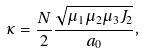<formula> <loc_0><loc_0><loc_500><loc_500>\kappa = \frac { N } { 2 } \frac { \sqrt { \mu _ { 1 } \mu _ { 2 } \mu _ { 3 } J _ { 2 } } } { a _ { 0 } } ,</formula> 